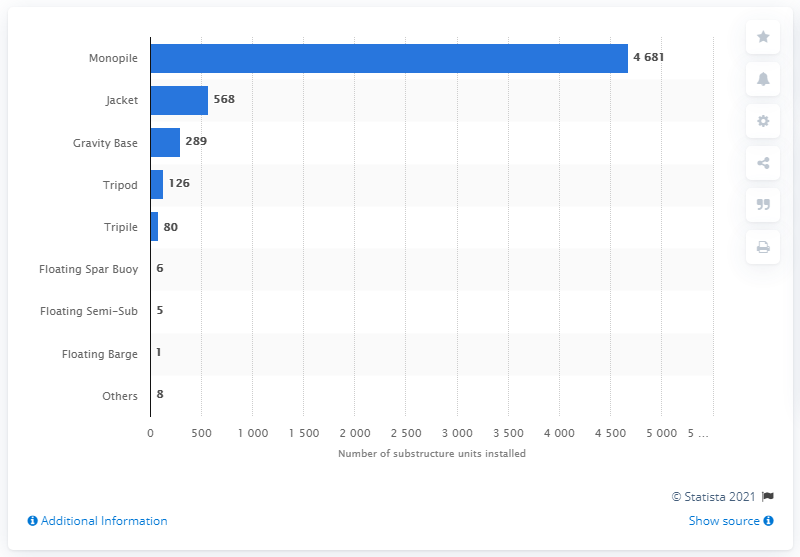Indicate a few pertinent items in this graphic. The most commonly used foundation type for wind turbines in Europe is monopile. 